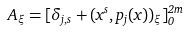Convert formula to latex. <formula><loc_0><loc_0><loc_500><loc_500>A _ { \xi } = [ \delta _ { j , s } + ( x ^ { s } , p _ { j } ( x ) ) _ { \xi } ] _ { 0 } ^ { 2 m }</formula> 